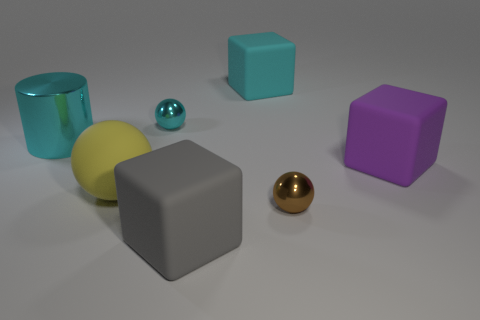Is there anything else that is the same size as the yellow matte ball? Yes, the silver metallic ball appears to be approximately the same size as the yellow matte ball. 